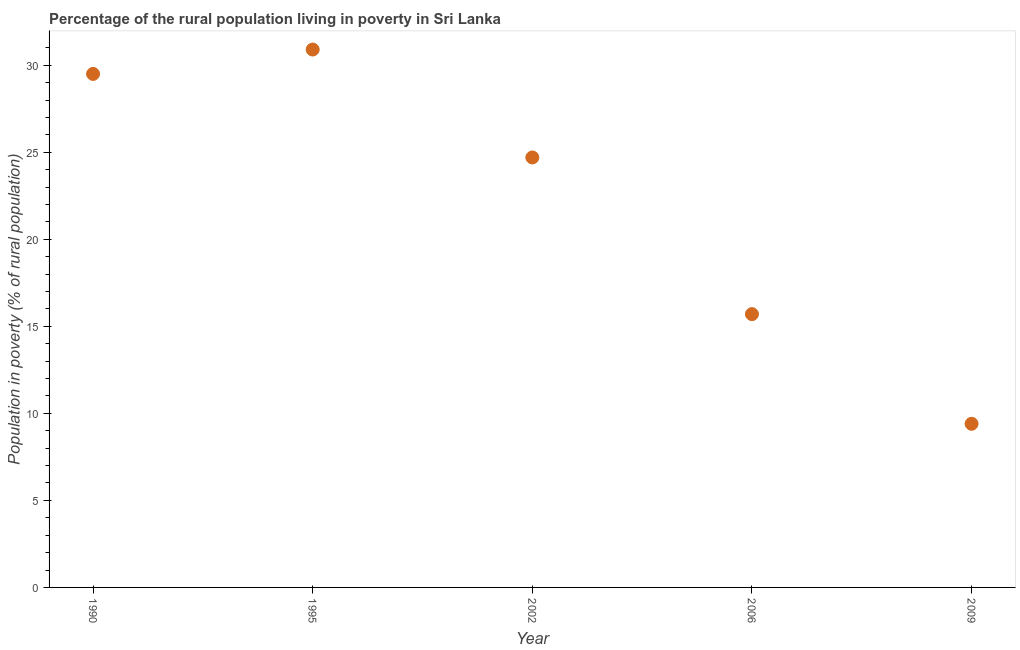What is the percentage of rural population living below poverty line in 2002?
Provide a short and direct response. 24.7. Across all years, what is the maximum percentage of rural population living below poverty line?
Provide a short and direct response. 30.9. What is the sum of the percentage of rural population living below poverty line?
Your answer should be very brief. 110.2. What is the difference between the percentage of rural population living below poverty line in 1990 and 1995?
Provide a succinct answer. -1.4. What is the average percentage of rural population living below poverty line per year?
Ensure brevity in your answer.  22.04. What is the median percentage of rural population living below poverty line?
Provide a succinct answer. 24.7. What is the ratio of the percentage of rural population living below poverty line in 2006 to that in 2009?
Your answer should be compact. 1.67. Is the difference between the percentage of rural population living below poverty line in 1990 and 2009 greater than the difference between any two years?
Give a very brief answer. No. What is the difference between the highest and the second highest percentage of rural population living below poverty line?
Ensure brevity in your answer.  1.4. In how many years, is the percentage of rural population living below poverty line greater than the average percentage of rural population living below poverty line taken over all years?
Your answer should be very brief. 3. Does the percentage of rural population living below poverty line monotonically increase over the years?
Offer a very short reply. No. How many dotlines are there?
Ensure brevity in your answer.  1. What is the title of the graph?
Offer a terse response. Percentage of the rural population living in poverty in Sri Lanka. What is the label or title of the Y-axis?
Provide a succinct answer. Population in poverty (% of rural population). What is the Population in poverty (% of rural population) in 1990?
Your answer should be compact. 29.5. What is the Population in poverty (% of rural population) in 1995?
Offer a terse response. 30.9. What is the Population in poverty (% of rural population) in 2002?
Provide a short and direct response. 24.7. What is the Population in poverty (% of rural population) in 2006?
Your answer should be compact. 15.7. What is the Population in poverty (% of rural population) in 2009?
Offer a very short reply. 9.4. What is the difference between the Population in poverty (% of rural population) in 1990 and 2009?
Ensure brevity in your answer.  20.1. What is the difference between the Population in poverty (% of rural population) in 1995 and 2009?
Your response must be concise. 21.5. What is the ratio of the Population in poverty (% of rural population) in 1990 to that in 1995?
Your answer should be very brief. 0.95. What is the ratio of the Population in poverty (% of rural population) in 1990 to that in 2002?
Offer a terse response. 1.19. What is the ratio of the Population in poverty (% of rural population) in 1990 to that in 2006?
Offer a very short reply. 1.88. What is the ratio of the Population in poverty (% of rural population) in 1990 to that in 2009?
Offer a very short reply. 3.14. What is the ratio of the Population in poverty (% of rural population) in 1995 to that in 2002?
Give a very brief answer. 1.25. What is the ratio of the Population in poverty (% of rural population) in 1995 to that in 2006?
Offer a terse response. 1.97. What is the ratio of the Population in poverty (% of rural population) in 1995 to that in 2009?
Provide a succinct answer. 3.29. What is the ratio of the Population in poverty (% of rural population) in 2002 to that in 2006?
Provide a succinct answer. 1.57. What is the ratio of the Population in poverty (% of rural population) in 2002 to that in 2009?
Offer a very short reply. 2.63. What is the ratio of the Population in poverty (% of rural population) in 2006 to that in 2009?
Ensure brevity in your answer.  1.67. 